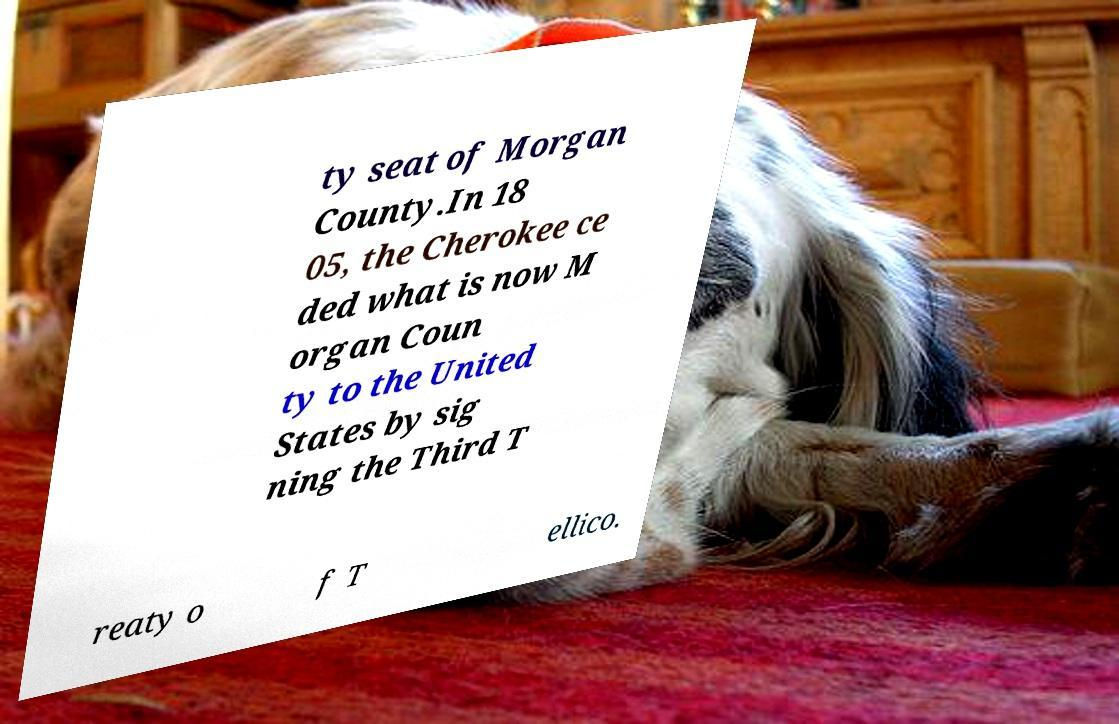What messages or text are displayed in this image? I need them in a readable, typed format. ty seat of Morgan County.In 18 05, the Cherokee ce ded what is now M organ Coun ty to the United States by sig ning the Third T reaty o f T ellico. 